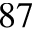Convert formula to latex. <formula><loc_0><loc_0><loc_500><loc_500>^ { 8 7 }</formula> 